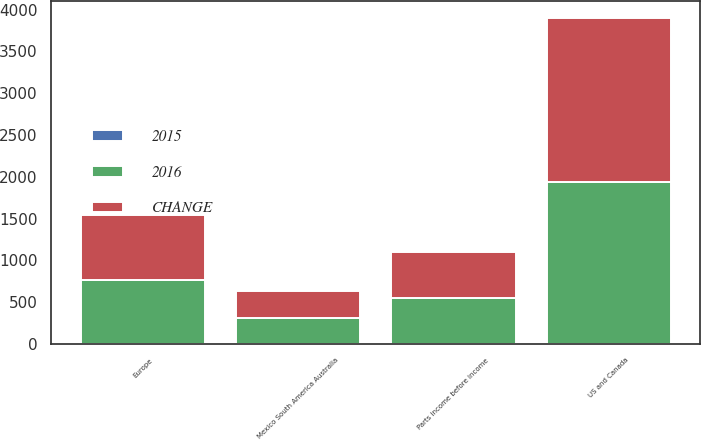Convert chart to OTSL. <chart><loc_0><loc_0><loc_500><loc_500><stacked_bar_chart><ecel><fcel>US and Canada<fcel>Europe<fcel>Mexico South America Australia<fcel>Parts income before income<nl><fcel>2016<fcel>1932.7<fcel>761.8<fcel>311.2<fcel>543.8<nl><fcel>CHANGE<fcel>1969.4<fcel>773.9<fcel>316.8<fcel>555.6<nl><fcel>2015<fcel>2<fcel>2<fcel>2<fcel>2<nl></chart> 